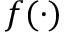<formula> <loc_0><loc_0><loc_500><loc_500>f ( \cdot )</formula> 